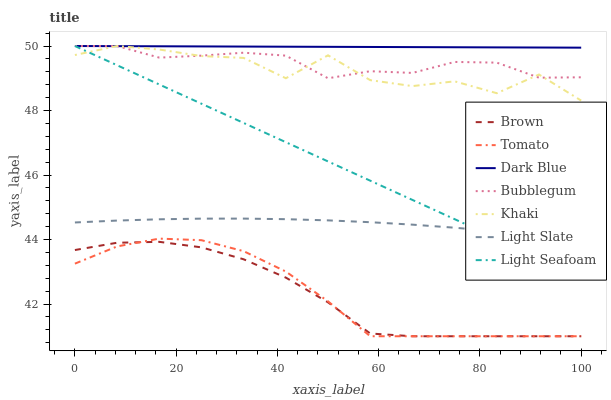Does Brown have the minimum area under the curve?
Answer yes or no. Yes. Does Dark Blue have the maximum area under the curve?
Answer yes or no. Yes. Does Khaki have the minimum area under the curve?
Answer yes or no. No. Does Khaki have the maximum area under the curve?
Answer yes or no. No. Is Light Seafoam the smoothest?
Answer yes or no. Yes. Is Khaki the roughest?
Answer yes or no. Yes. Is Brown the smoothest?
Answer yes or no. No. Is Brown the roughest?
Answer yes or no. No. Does Tomato have the lowest value?
Answer yes or no. Yes. Does Khaki have the lowest value?
Answer yes or no. No. Does Light Seafoam have the highest value?
Answer yes or no. Yes. Does Brown have the highest value?
Answer yes or no. No. Is Light Slate less than Bubblegum?
Answer yes or no. Yes. Is Dark Blue greater than Brown?
Answer yes or no. Yes. Does Dark Blue intersect Light Seafoam?
Answer yes or no. Yes. Is Dark Blue less than Light Seafoam?
Answer yes or no. No. Is Dark Blue greater than Light Seafoam?
Answer yes or no. No. Does Light Slate intersect Bubblegum?
Answer yes or no. No. 